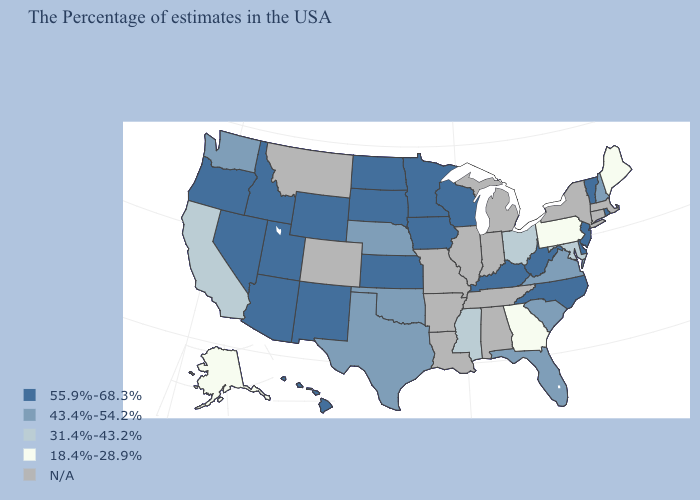What is the highest value in states that border Pennsylvania?
Keep it brief. 55.9%-68.3%. What is the highest value in states that border Louisiana?
Answer briefly. 43.4%-54.2%. What is the value of Tennessee?
Be succinct. N/A. Name the states that have a value in the range 18.4%-28.9%?
Be succinct. Maine, Pennsylvania, Georgia, Alaska. Among the states that border Indiana , does Ohio have the highest value?
Give a very brief answer. No. Name the states that have a value in the range N/A?
Short answer required. Massachusetts, Connecticut, New York, Michigan, Indiana, Alabama, Tennessee, Illinois, Louisiana, Missouri, Arkansas, Colorado, Montana. What is the value of Idaho?
Short answer required. 55.9%-68.3%. What is the highest value in states that border New Hampshire?
Quick response, please. 55.9%-68.3%. Does the map have missing data?
Quick response, please. Yes. Name the states that have a value in the range 55.9%-68.3%?
Write a very short answer. Rhode Island, Vermont, New Jersey, Delaware, North Carolina, West Virginia, Kentucky, Wisconsin, Minnesota, Iowa, Kansas, South Dakota, North Dakota, Wyoming, New Mexico, Utah, Arizona, Idaho, Nevada, Oregon, Hawaii. Does Minnesota have the highest value in the USA?
Be succinct. Yes. Name the states that have a value in the range 31.4%-43.2%?
Give a very brief answer. Maryland, Ohio, Mississippi, California. Among the states that border California , which have the lowest value?
Be succinct. Arizona, Nevada, Oregon. Is the legend a continuous bar?
Answer briefly. No. What is the lowest value in states that border Idaho?
Quick response, please. 43.4%-54.2%. 